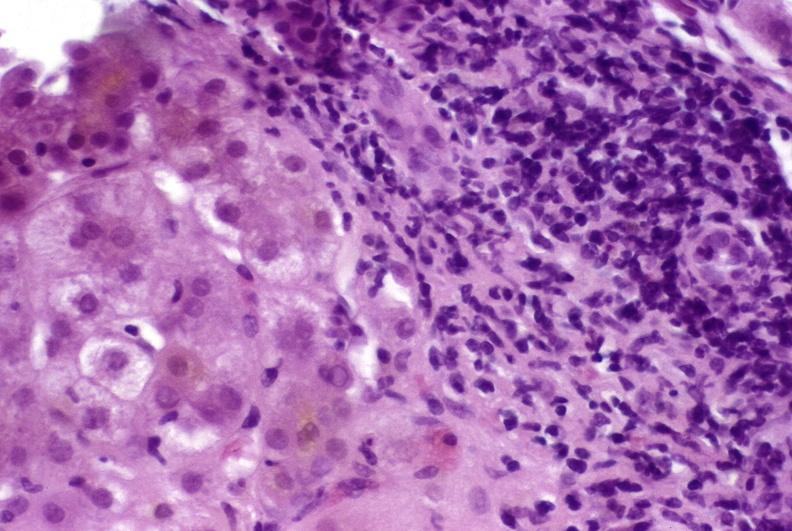does this image show autoimmune hepatitis?
Answer the question using a single word or phrase. Yes 